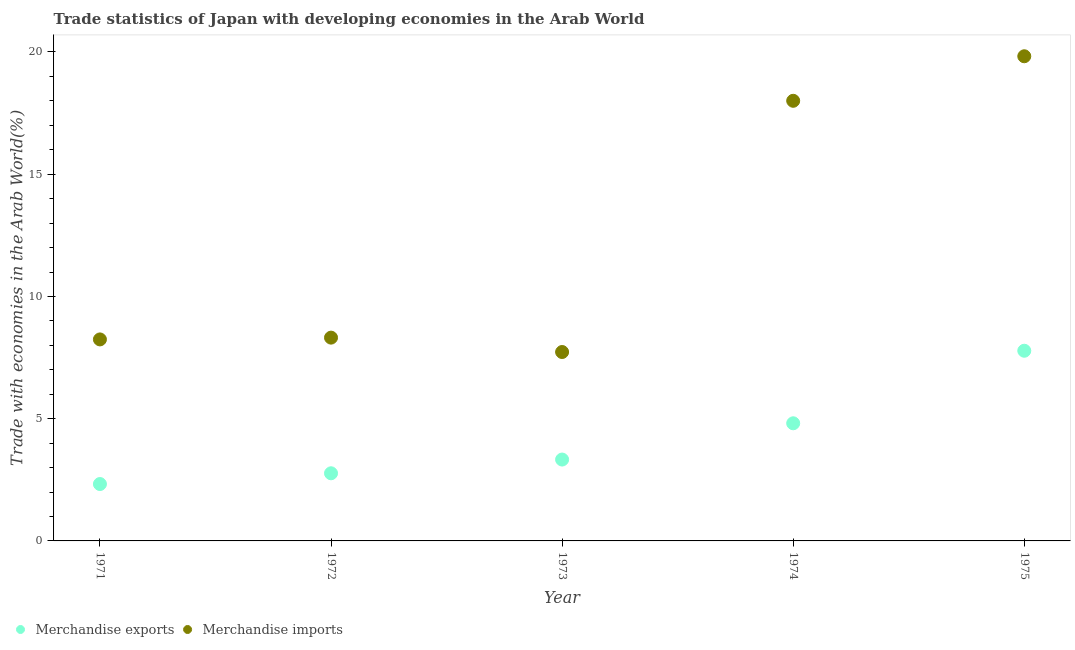Is the number of dotlines equal to the number of legend labels?
Your answer should be very brief. Yes. What is the merchandise exports in 1972?
Your response must be concise. 2.77. Across all years, what is the maximum merchandise imports?
Your response must be concise. 19.83. Across all years, what is the minimum merchandise exports?
Provide a succinct answer. 2.33. In which year was the merchandise imports maximum?
Provide a short and direct response. 1975. What is the total merchandise imports in the graph?
Give a very brief answer. 62.12. What is the difference between the merchandise exports in 1972 and that in 1974?
Ensure brevity in your answer.  -2.05. What is the difference between the merchandise exports in 1972 and the merchandise imports in 1974?
Keep it short and to the point. -15.24. What is the average merchandise imports per year?
Provide a succinct answer. 12.42. In the year 1971, what is the difference between the merchandise imports and merchandise exports?
Offer a very short reply. 5.92. What is the ratio of the merchandise imports in 1971 to that in 1975?
Your answer should be very brief. 0.42. What is the difference between the highest and the second highest merchandise exports?
Your answer should be compact. 2.97. What is the difference between the highest and the lowest merchandise exports?
Give a very brief answer. 5.45. Is the sum of the merchandise imports in 1972 and 1975 greater than the maximum merchandise exports across all years?
Provide a succinct answer. Yes. Is the merchandise imports strictly less than the merchandise exports over the years?
Ensure brevity in your answer.  No. Where does the legend appear in the graph?
Keep it short and to the point. Bottom left. What is the title of the graph?
Make the answer very short. Trade statistics of Japan with developing economies in the Arab World. Does "Rural" appear as one of the legend labels in the graph?
Provide a succinct answer. No. What is the label or title of the Y-axis?
Offer a terse response. Trade with economies in the Arab World(%). What is the Trade with economies in the Arab World(%) of Merchandise exports in 1971?
Make the answer very short. 2.33. What is the Trade with economies in the Arab World(%) in Merchandise imports in 1971?
Your response must be concise. 8.24. What is the Trade with economies in the Arab World(%) in Merchandise exports in 1972?
Offer a terse response. 2.77. What is the Trade with economies in the Arab World(%) in Merchandise imports in 1972?
Provide a short and direct response. 8.32. What is the Trade with economies in the Arab World(%) in Merchandise exports in 1973?
Provide a short and direct response. 3.33. What is the Trade with economies in the Arab World(%) of Merchandise imports in 1973?
Offer a terse response. 7.73. What is the Trade with economies in the Arab World(%) of Merchandise exports in 1974?
Your answer should be very brief. 4.81. What is the Trade with economies in the Arab World(%) of Merchandise imports in 1974?
Your answer should be compact. 18. What is the Trade with economies in the Arab World(%) of Merchandise exports in 1975?
Give a very brief answer. 7.78. What is the Trade with economies in the Arab World(%) of Merchandise imports in 1975?
Make the answer very short. 19.83. Across all years, what is the maximum Trade with economies in the Arab World(%) of Merchandise exports?
Your answer should be compact. 7.78. Across all years, what is the maximum Trade with economies in the Arab World(%) in Merchandise imports?
Give a very brief answer. 19.83. Across all years, what is the minimum Trade with economies in the Arab World(%) of Merchandise exports?
Keep it short and to the point. 2.33. Across all years, what is the minimum Trade with economies in the Arab World(%) in Merchandise imports?
Offer a very short reply. 7.73. What is the total Trade with economies in the Arab World(%) in Merchandise exports in the graph?
Ensure brevity in your answer.  21.01. What is the total Trade with economies in the Arab World(%) of Merchandise imports in the graph?
Make the answer very short. 62.12. What is the difference between the Trade with economies in the Arab World(%) in Merchandise exports in 1971 and that in 1972?
Give a very brief answer. -0.44. What is the difference between the Trade with economies in the Arab World(%) of Merchandise imports in 1971 and that in 1972?
Your answer should be very brief. -0.07. What is the difference between the Trade with economies in the Arab World(%) of Merchandise exports in 1971 and that in 1973?
Offer a terse response. -1. What is the difference between the Trade with economies in the Arab World(%) of Merchandise imports in 1971 and that in 1973?
Keep it short and to the point. 0.52. What is the difference between the Trade with economies in the Arab World(%) in Merchandise exports in 1971 and that in 1974?
Ensure brevity in your answer.  -2.48. What is the difference between the Trade with economies in the Arab World(%) of Merchandise imports in 1971 and that in 1974?
Give a very brief answer. -9.76. What is the difference between the Trade with economies in the Arab World(%) of Merchandise exports in 1971 and that in 1975?
Offer a very short reply. -5.45. What is the difference between the Trade with economies in the Arab World(%) in Merchandise imports in 1971 and that in 1975?
Provide a short and direct response. -11.58. What is the difference between the Trade with economies in the Arab World(%) in Merchandise exports in 1972 and that in 1973?
Keep it short and to the point. -0.56. What is the difference between the Trade with economies in the Arab World(%) of Merchandise imports in 1972 and that in 1973?
Your answer should be very brief. 0.59. What is the difference between the Trade with economies in the Arab World(%) in Merchandise exports in 1972 and that in 1974?
Offer a terse response. -2.05. What is the difference between the Trade with economies in the Arab World(%) of Merchandise imports in 1972 and that in 1974?
Offer a terse response. -9.69. What is the difference between the Trade with economies in the Arab World(%) of Merchandise exports in 1972 and that in 1975?
Give a very brief answer. -5.01. What is the difference between the Trade with economies in the Arab World(%) of Merchandise imports in 1972 and that in 1975?
Offer a terse response. -11.51. What is the difference between the Trade with economies in the Arab World(%) in Merchandise exports in 1973 and that in 1974?
Provide a short and direct response. -1.48. What is the difference between the Trade with economies in the Arab World(%) in Merchandise imports in 1973 and that in 1974?
Keep it short and to the point. -10.28. What is the difference between the Trade with economies in the Arab World(%) in Merchandise exports in 1973 and that in 1975?
Ensure brevity in your answer.  -4.45. What is the difference between the Trade with economies in the Arab World(%) in Merchandise imports in 1973 and that in 1975?
Offer a very short reply. -12.1. What is the difference between the Trade with economies in the Arab World(%) of Merchandise exports in 1974 and that in 1975?
Offer a very short reply. -2.97. What is the difference between the Trade with economies in the Arab World(%) of Merchandise imports in 1974 and that in 1975?
Offer a terse response. -1.82. What is the difference between the Trade with economies in the Arab World(%) of Merchandise exports in 1971 and the Trade with economies in the Arab World(%) of Merchandise imports in 1972?
Your answer should be very brief. -5.99. What is the difference between the Trade with economies in the Arab World(%) in Merchandise exports in 1971 and the Trade with economies in the Arab World(%) in Merchandise imports in 1973?
Your answer should be compact. -5.4. What is the difference between the Trade with economies in the Arab World(%) in Merchandise exports in 1971 and the Trade with economies in the Arab World(%) in Merchandise imports in 1974?
Offer a very short reply. -15.68. What is the difference between the Trade with economies in the Arab World(%) in Merchandise exports in 1971 and the Trade with economies in the Arab World(%) in Merchandise imports in 1975?
Provide a short and direct response. -17.5. What is the difference between the Trade with economies in the Arab World(%) of Merchandise exports in 1972 and the Trade with economies in the Arab World(%) of Merchandise imports in 1973?
Your answer should be compact. -4.96. What is the difference between the Trade with economies in the Arab World(%) of Merchandise exports in 1972 and the Trade with economies in the Arab World(%) of Merchandise imports in 1974?
Your answer should be very brief. -15.24. What is the difference between the Trade with economies in the Arab World(%) of Merchandise exports in 1972 and the Trade with economies in the Arab World(%) of Merchandise imports in 1975?
Offer a very short reply. -17.06. What is the difference between the Trade with economies in the Arab World(%) in Merchandise exports in 1973 and the Trade with economies in the Arab World(%) in Merchandise imports in 1974?
Offer a very short reply. -14.68. What is the difference between the Trade with economies in the Arab World(%) of Merchandise exports in 1973 and the Trade with economies in the Arab World(%) of Merchandise imports in 1975?
Your answer should be compact. -16.5. What is the difference between the Trade with economies in the Arab World(%) of Merchandise exports in 1974 and the Trade with economies in the Arab World(%) of Merchandise imports in 1975?
Your answer should be very brief. -15.01. What is the average Trade with economies in the Arab World(%) in Merchandise exports per year?
Keep it short and to the point. 4.2. What is the average Trade with economies in the Arab World(%) in Merchandise imports per year?
Provide a short and direct response. 12.42. In the year 1971, what is the difference between the Trade with economies in the Arab World(%) in Merchandise exports and Trade with economies in the Arab World(%) in Merchandise imports?
Your response must be concise. -5.92. In the year 1972, what is the difference between the Trade with economies in the Arab World(%) of Merchandise exports and Trade with economies in the Arab World(%) of Merchandise imports?
Your answer should be very brief. -5.55. In the year 1973, what is the difference between the Trade with economies in the Arab World(%) of Merchandise exports and Trade with economies in the Arab World(%) of Merchandise imports?
Ensure brevity in your answer.  -4.4. In the year 1974, what is the difference between the Trade with economies in the Arab World(%) of Merchandise exports and Trade with economies in the Arab World(%) of Merchandise imports?
Provide a short and direct response. -13.19. In the year 1975, what is the difference between the Trade with economies in the Arab World(%) of Merchandise exports and Trade with economies in the Arab World(%) of Merchandise imports?
Provide a short and direct response. -12.05. What is the ratio of the Trade with economies in the Arab World(%) in Merchandise exports in 1971 to that in 1972?
Provide a succinct answer. 0.84. What is the ratio of the Trade with economies in the Arab World(%) in Merchandise exports in 1971 to that in 1973?
Offer a terse response. 0.7. What is the ratio of the Trade with economies in the Arab World(%) of Merchandise imports in 1971 to that in 1973?
Your answer should be very brief. 1.07. What is the ratio of the Trade with economies in the Arab World(%) in Merchandise exports in 1971 to that in 1974?
Give a very brief answer. 0.48. What is the ratio of the Trade with economies in the Arab World(%) in Merchandise imports in 1971 to that in 1974?
Give a very brief answer. 0.46. What is the ratio of the Trade with economies in the Arab World(%) of Merchandise exports in 1971 to that in 1975?
Provide a succinct answer. 0.3. What is the ratio of the Trade with economies in the Arab World(%) in Merchandise imports in 1971 to that in 1975?
Your response must be concise. 0.42. What is the ratio of the Trade with economies in the Arab World(%) in Merchandise exports in 1972 to that in 1973?
Your answer should be very brief. 0.83. What is the ratio of the Trade with economies in the Arab World(%) in Merchandise imports in 1972 to that in 1973?
Your answer should be very brief. 1.08. What is the ratio of the Trade with economies in the Arab World(%) of Merchandise exports in 1972 to that in 1974?
Your answer should be compact. 0.57. What is the ratio of the Trade with economies in the Arab World(%) in Merchandise imports in 1972 to that in 1974?
Your response must be concise. 0.46. What is the ratio of the Trade with economies in the Arab World(%) in Merchandise exports in 1972 to that in 1975?
Offer a very short reply. 0.36. What is the ratio of the Trade with economies in the Arab World(%) of Merchandise imports in 1972 to that in 1975?
Ensure brevity in your answer.  0.42. What is the ratio of the Trade with economies in the Arab World(%) in Merchandise exports in 1973 to that in 1974?
Offer a very short reply. 0.69. What is the ratio of the Trade with economies in the Arab World(%) of Merchandise imports in 1973 to that in 1974?
Provide a succinct answer. 0.43. What is the ratio of the Trade with economies in the Arab World(%) in Merchandise exports in 1973 to that in 1975?
Give a very brief answer. 0.43. What is the ratio of the Trade with economies in the Arab World(%) in Merchandise imports in 1973 to that in 1975?
Keep it short and to the point. 0.39. What is the ratio of the Trade with economies in the Arab World(%) in Merchandise exports in 1974 to that in 1975?
Ensure brevity in your answer.  0.62. What is the ratio of the Trade with economies in the Arab World(%) of Merchandise imports in 1974 to that in 1975?
Your answer should be compact. 0.91. What is the difference between the highest and the second highest Trade with economies in the Arab World(%) of Merchandise exports?
Provide a short and direct response. 2.97. What is the difference between the highest and the second highest Trade with economies in the Arab World(%) in Merchandise imports?
Make the answer very short. 1.82. What is the difference between the highest and the lowest Trade with economies in the Arab World(%) of Merchandise exports?
Give a very brief answer. 5.45. What is the difference between the highest and the lowest Trade with economies in the Arab World(%) in Merchandise imports?
Offer a terse response. 12.1. 